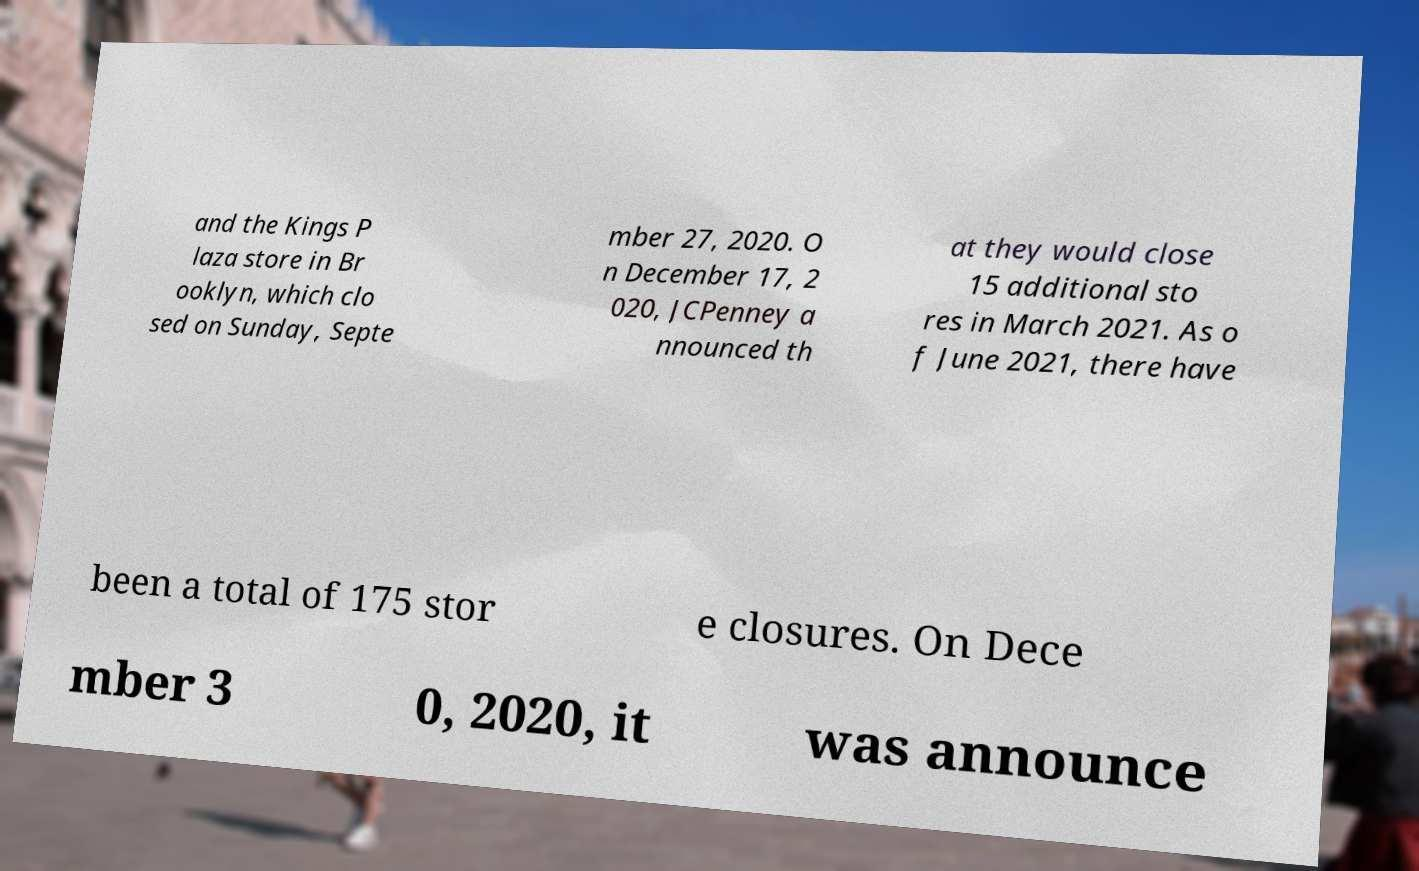There's text embedded in this image that I need extracted. Can you transcribe it verbatim? and the Kings P laza store in Br ooklyn, which clo sed on Sunday, Septe mber 27, 2020. O n December 17, 2 020, JCPenney a nnounced th at they would close 15 additional sto res in March 2021. As o f June 2021, there have been a total of 175 stor e closures. On Dece mber 3 0, 2020, it was announce 